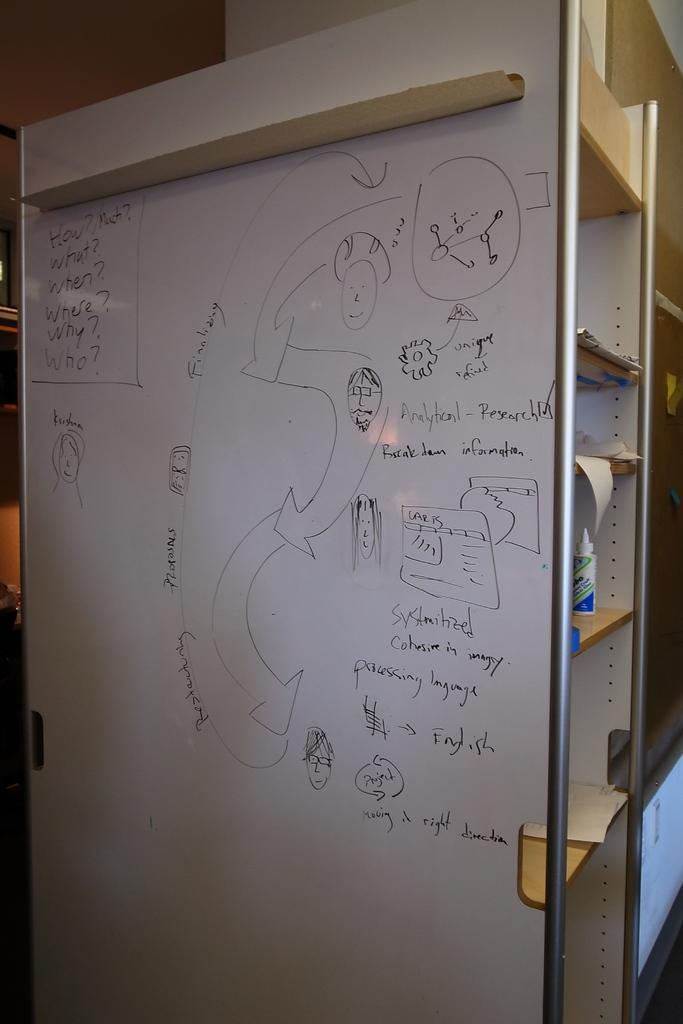<image>
Give a short and clear explanation of the subsequent image. a white board with a map of people and words How, Much and What 